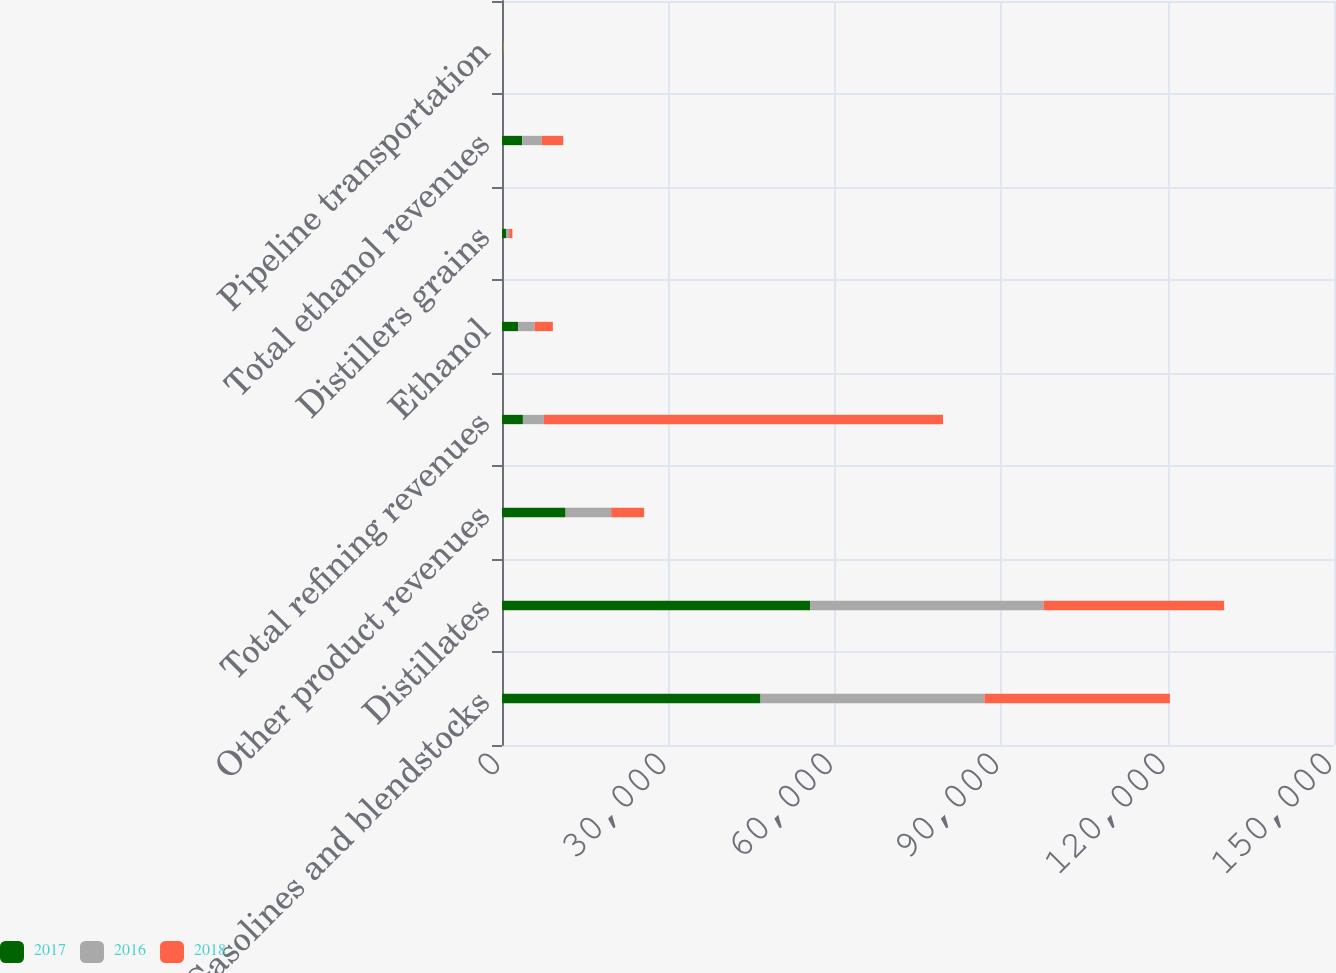Convert chart to OTSL. <chart><loc_0><loc_0><loc_500><loc_500><stacked_bar_chart><ecel><fcel>Gasolines and blendstocks<fcel>Distillates<fcel>Other product revenues<fcel>Total refining revenues<fcel>Ethanol<fcel>Distillers grains<fcel>Total ethanol revenues<fcel>Pipeline transportation<nl><fcel>2017<fcel>46606<fcel>55546<fcel>11463<fcel>3769.5<fcel>2912<fcel>726<fcel>3638<fcel>124<nl><fcel>2016<fcel>40366<fcel>42074<fcel>8217<fcel>3769.5<fcel>2940<fcel>560<fcel>3500<fcel>101<nl><fcel>2018<fcel>33450<fcel>32576<fcel>5942<fcel>71968<fcel>3315<fcel>586<fcel>3901<fcel>78<nl></chart> 